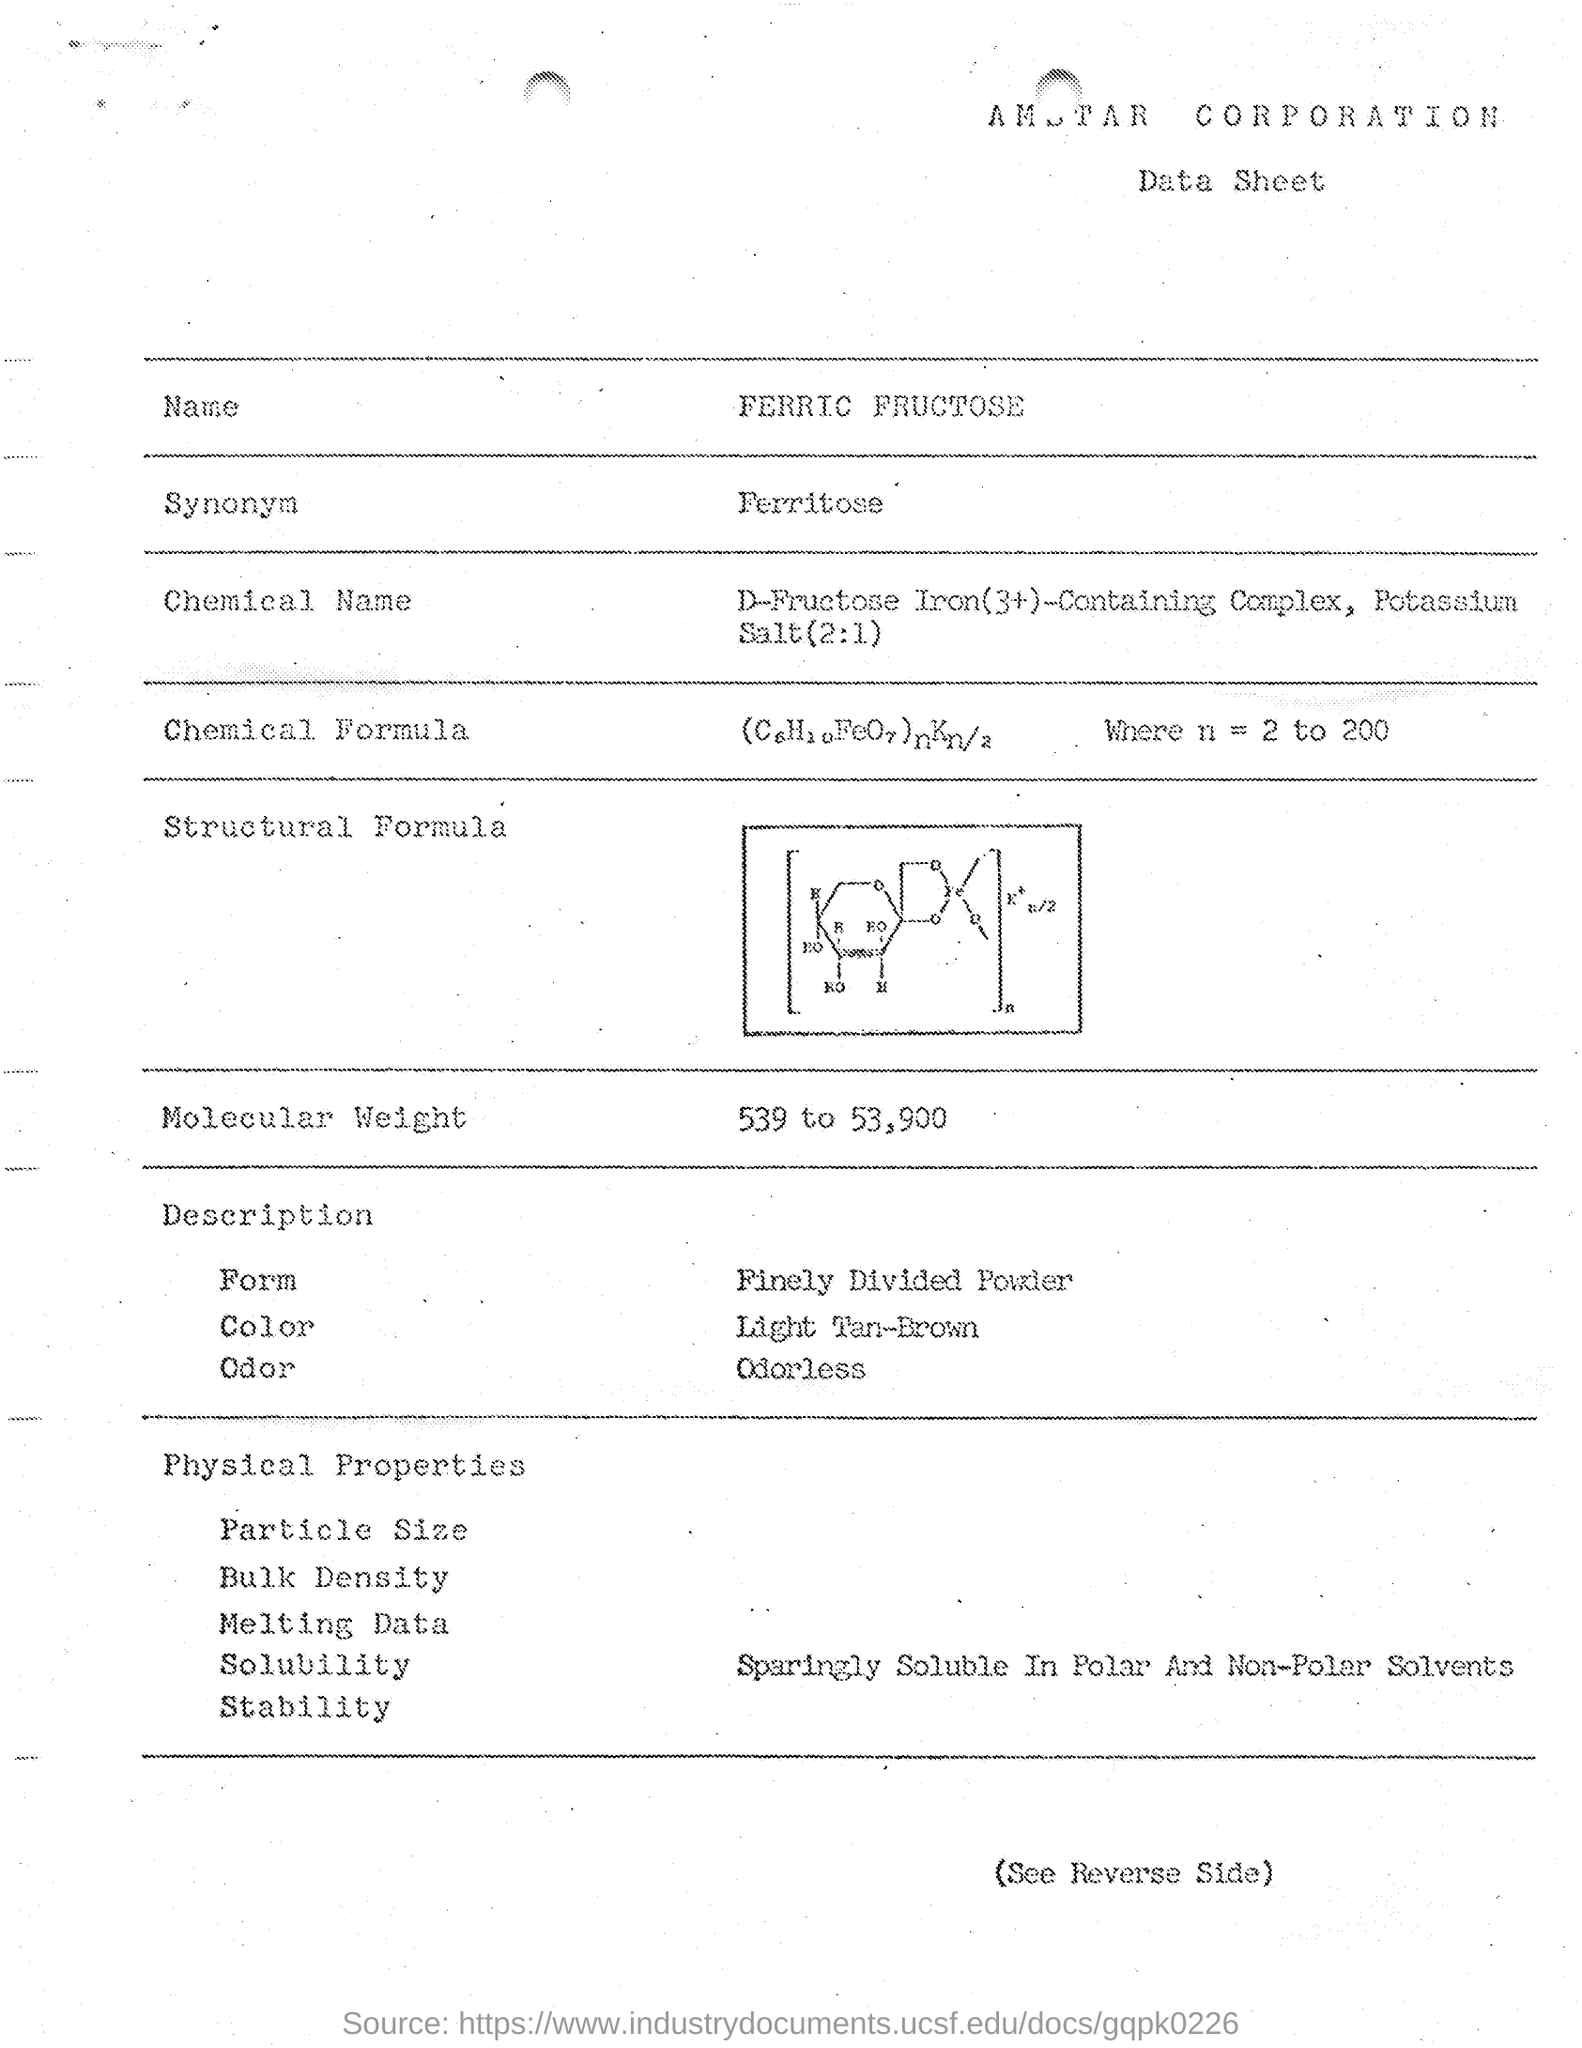Draw attention to some important aspects in this diagram. Ferric fructose is synonymous with ferritose. 